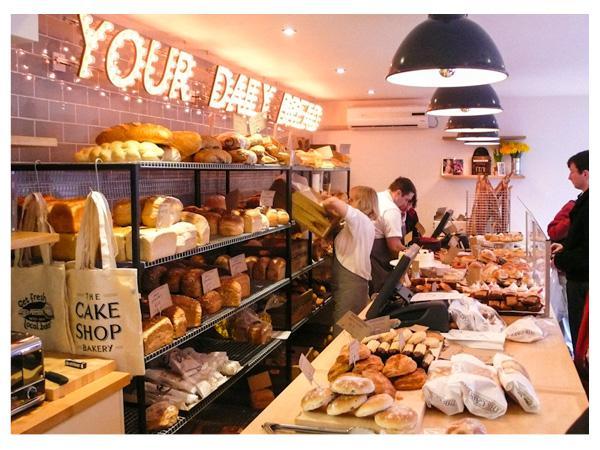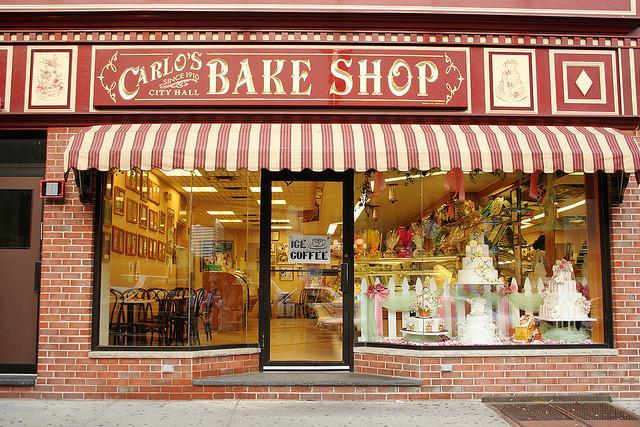The first image is the image on the left, the second image is the image on the right. Analyze the images presented: Is the assertion "The shop door is at least partially visible in the iamge on the right" valid? Answer yes or no. Yes. The first image is the image on the left, the second image is the image on the right. Evaluate the accuracy of this statement regarding the images: "A black railed wheeled display is on the right in one image.". Is it true? Answer yes or no. No. 